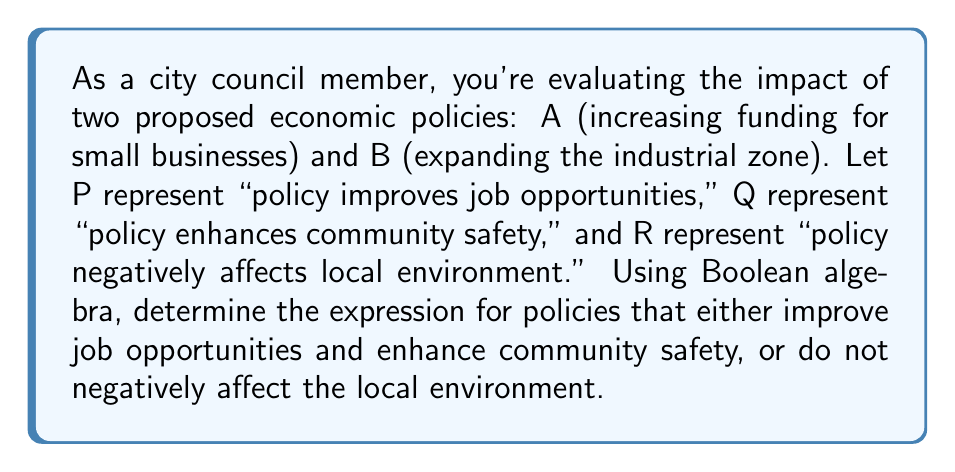Can you answer this question? Let's approach this step-by-step using Boolean algebra:

1) First, we need to define our variables:
   A: Policy of increasing funding for small businesses
   B: Policy of expanding the industrial zone
   P: Policy improves job opportunities
   Q: Policy enhances community safety
   R: Policy negatively affects local environment

2) The question asks for policies that satisfy either of two conditions:
   - Improve job opportunities AND enhance community safety
   - Do not negatively affect the local environment

3) In Boolean algebra, this can be expressed as:

   $$(P \land Q) \lor \lnot R$$

4) Now, we need to evaluate this for both policies A and B. Let's assume:
   - Policy A: P = 1, Q = 1, R = 0
   - Policy B: P = 1, Q = 0, R = 1

5) For Policy A:
   $$(1 \land 1) \lor \lnot 0 = 1 \lor 1 = 1$$

6) For Policy B:
   $$(1 \land 0) \lor \lnot 1 = 0 \lor 0 = 0$$

7) The final expression that represents the desired outcome for both policies is:

   $$A \land (P \land Q) \lor \lnot R$$

This expression will evaluate to true (1) for policies that satisfy the given conditions.
Answer: $$A \land (P \land Q) \lor \lnot R$$ 